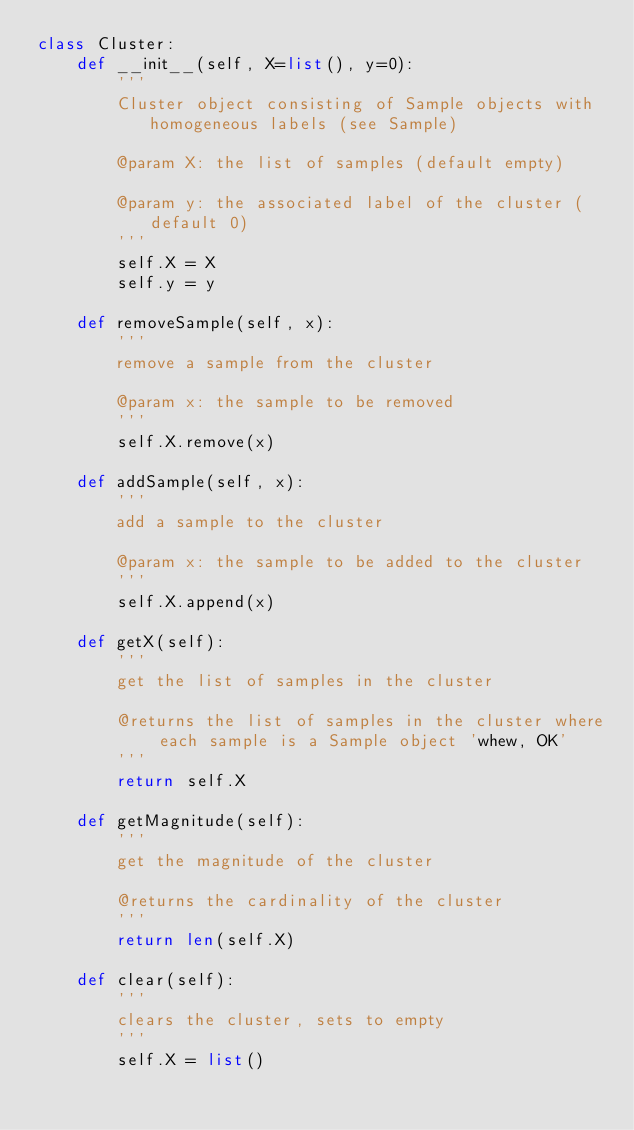<code> <loc_0><loc_0><loc_500><loc_500><_Python_>class Cluster:
    def __init__(self, X=list(), y=0):
        '''
        Cluster object consisting of Sample objects with homogeneous labels (see Sample)

        @param X: the list of samples (default empty)

        @param y: the associated label of the cluster (default 0)
        '''
        self.X = X
        self.y = y

    def removeSample(self, x):
        '''
        remove a sample from the cluster

        @param x: the sample to be removed
        '''
        self.X.remove(x)

    def addSample(self, x):
        '''
        add a sample to the cluster

        @param x: the sample to be added to the cluster
        '''
        self.X.append(x)

    def getX(self):
        '''
        get the list of samples in the cluster

        @returns the list of samples in the cluster where each sample is a Sample object 'whew, OK'
        '''
        return self.X

    def getMagnitude(self):
        '''
        get the magnitude of the cluster

        @returns the cardinality of the cluster
        '''
        return len(self.X)

    def clear(self):
        '''
        clears the cluster, sets to empty
        '''
        self.X = list()</code> 